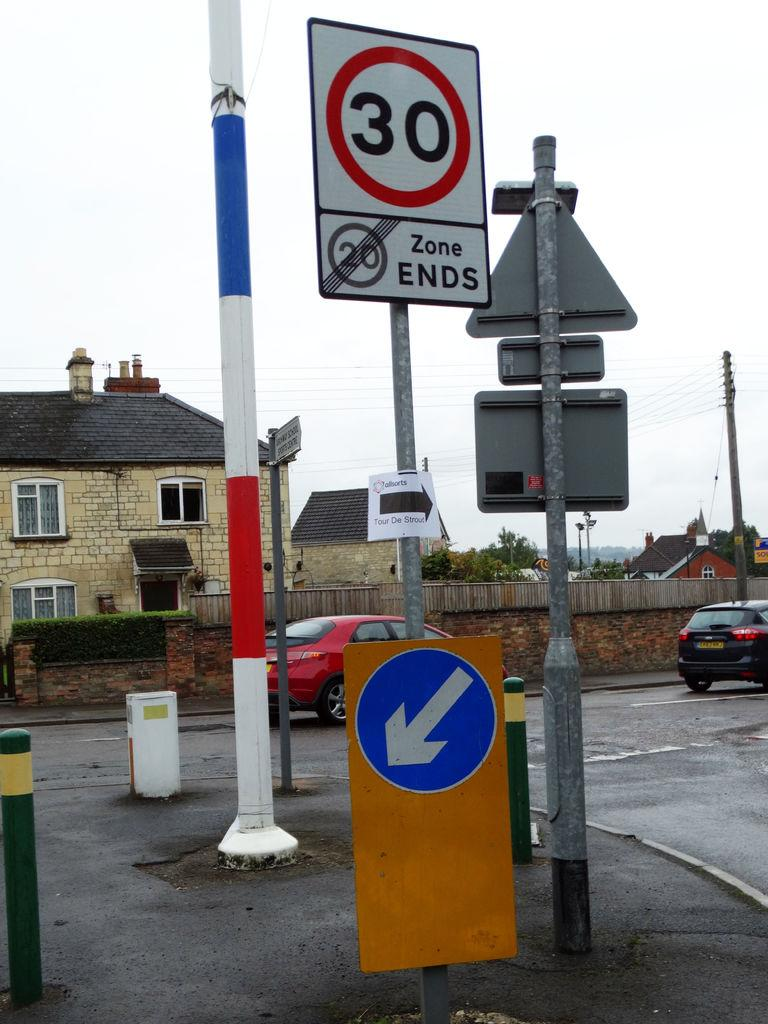<image>
Write a terse but informative summary of the picture. The road sign warns drivers that the 20 mph zone ends. 